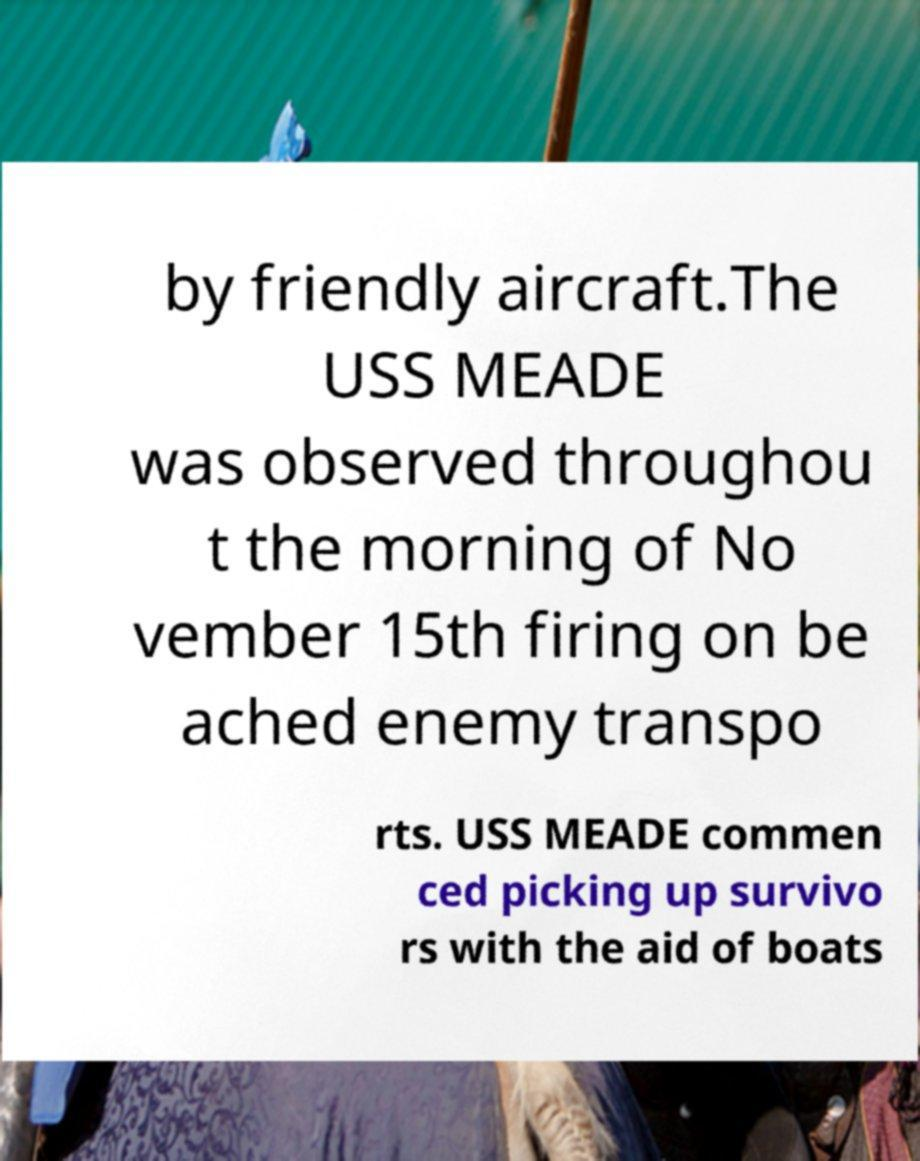Please identify and transcribe the text found in this image. by friendly aircraft.The USS MEADE was observed throughou t the morning of No vember 15th firing on be ached enemy transpo rts. USS MEADE commen ced picking up survivo rs with the aid of boats 